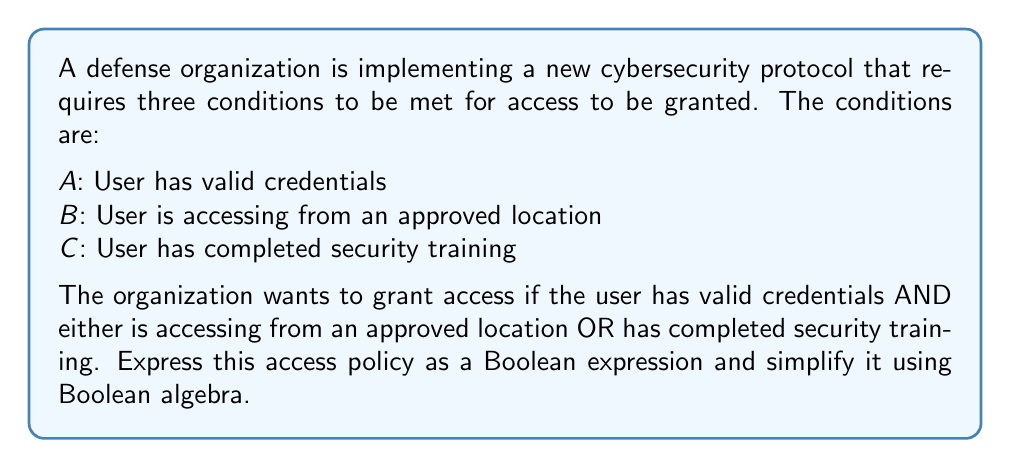Can you solve this math problem? Let's approach this step-by-step:

1) First, we need to translate the access policy into a Boolean expression:
   $$ A \text{ AND } (B \text{ OR } C) $$

2) We can write this using Boolean algebra notation:
   $$ A \cdot (B + C) $$

3) This expression is already in its simplest form, known as the Sum of Products (SOP) form. However, let's verify this using the distributive law:

   $$ A \cdot (B + C) = (A \cdot B) + (A \cdot C) $$

4) This expanded form is equivalent to our original expression, but it's not simpler. Therefore, our original expression $A \cdot (B + C)$ is indeed the simplest form.

5) To interpret this in terms of cybersecurity:
   - Access is granted only if condition A is true (user has valid credentials), AND
   - Either condition B is true (approved location) OR condition C is true (completed training)

This Boolean expression effectively represents the desired access policy, balancing security (requiring credentials) with flexibility (allowing either approved location or completed training).
Answer: $A \cdot (B + C)$ 